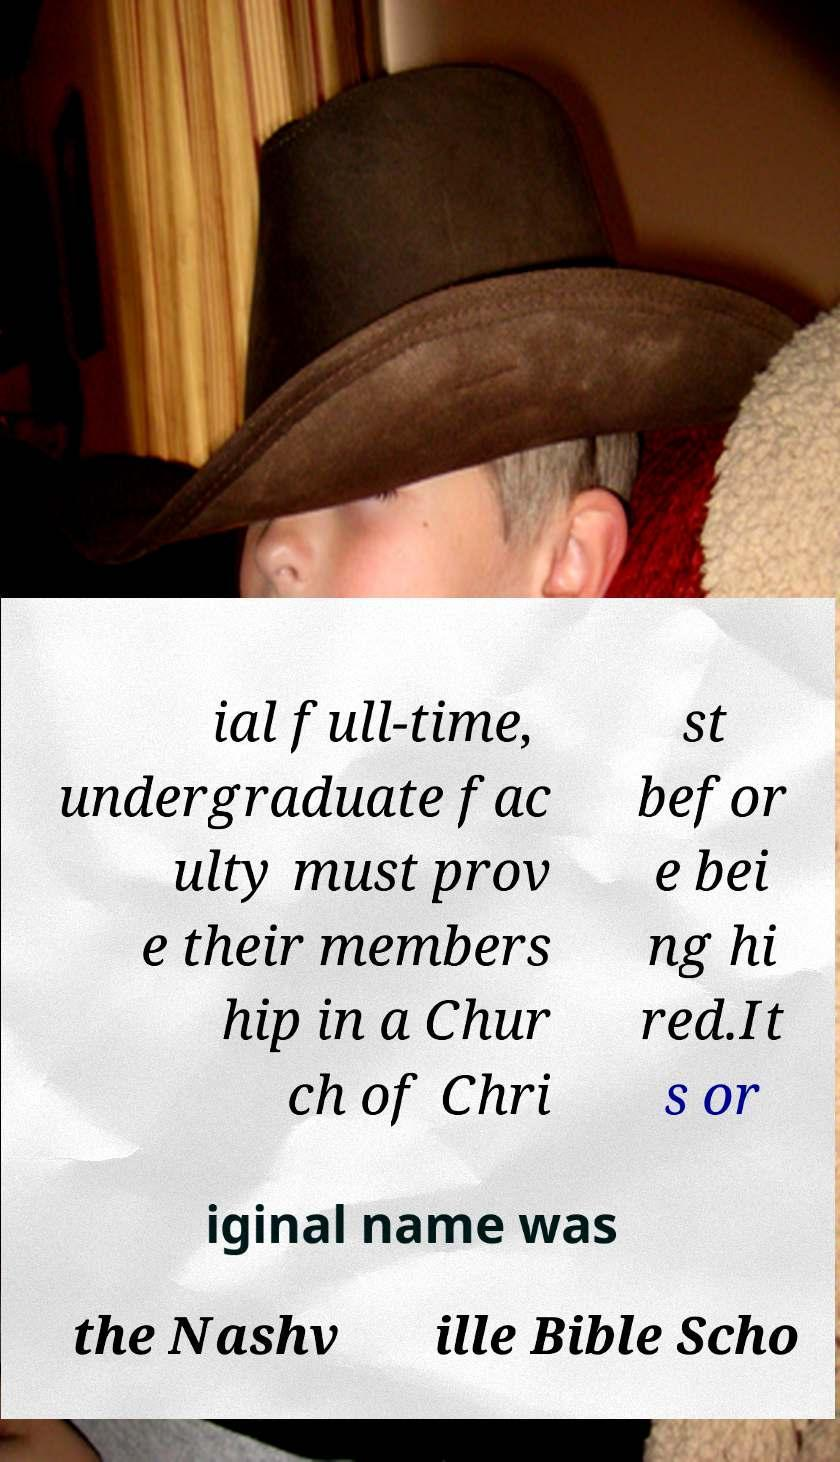Could you assist in decoding the text presented in this image and type it out clearly? ial full-time, undergraduate fac ulty must prov e their members hip in a Chur ch of Chri st befor e bei ng hi red.It s or iginal name was the Nashv ille Bible Scho 